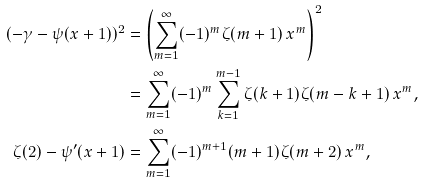Convert formula to latex. <formula><loc_0><loc_0><loc_500><loc_500>( - \gamma - \psi ( x + 1 ) ) ^ { 2 } & = \left ( \sum _ { m = 1 } ^ { \infty } ( - 1 ) ^ { m } \zeta ( m + 1 ) \, x ^ { m } \right ) ^ { 2 } \\ & = \sum _ { m = 1 } ^ { \infty } ( - 1 ) ^ { m } \sum _ { k = 1 } ^ { m - 1 } \zeta ( k + 1 ) \zeta ( m - k + 1 ) \, x ^ { m } , \\ \zeta ( 2 ) - \psi ^ { \prime } ( x + 1 ) & = \sum _ { m = 1 } ^ { \infty } ( - 1 ) ^ { m + 1 } ( m + 1 ) \zeta ( m + 2 ) \, x ^ { m } ,</formula> 